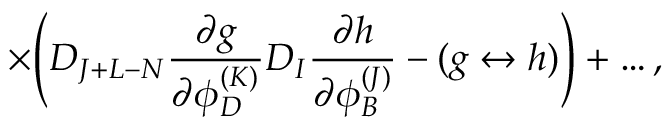<formula> <loc_0><loc_0><loc_500><loc_500>\times \left ( D _ { J + L - N } { \frac { \partial g } { \partial \phi _ { D } ^ { ( K ) } } } D _ { I } { \frac { \partial h } { \partial \phi _ { B } ^ { ( J ) } } } - ( g \leftrightarrow h ) \right ) + \dots ,</formula> 